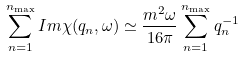Convert formula to latex. <formula><loc_0><loc_0><loc_500><loc_500>\sum ^ { n _ { \max } } _ { n = 1 } I m \chi ( q _ { n } , \omega ) \simeq \frac { m ^ { 2 } \omega } { 1 6 \pi } \sum ^ { n _ { \max } } _ { n = 1 } q _ { n } ^ { - 1 }</formula> 